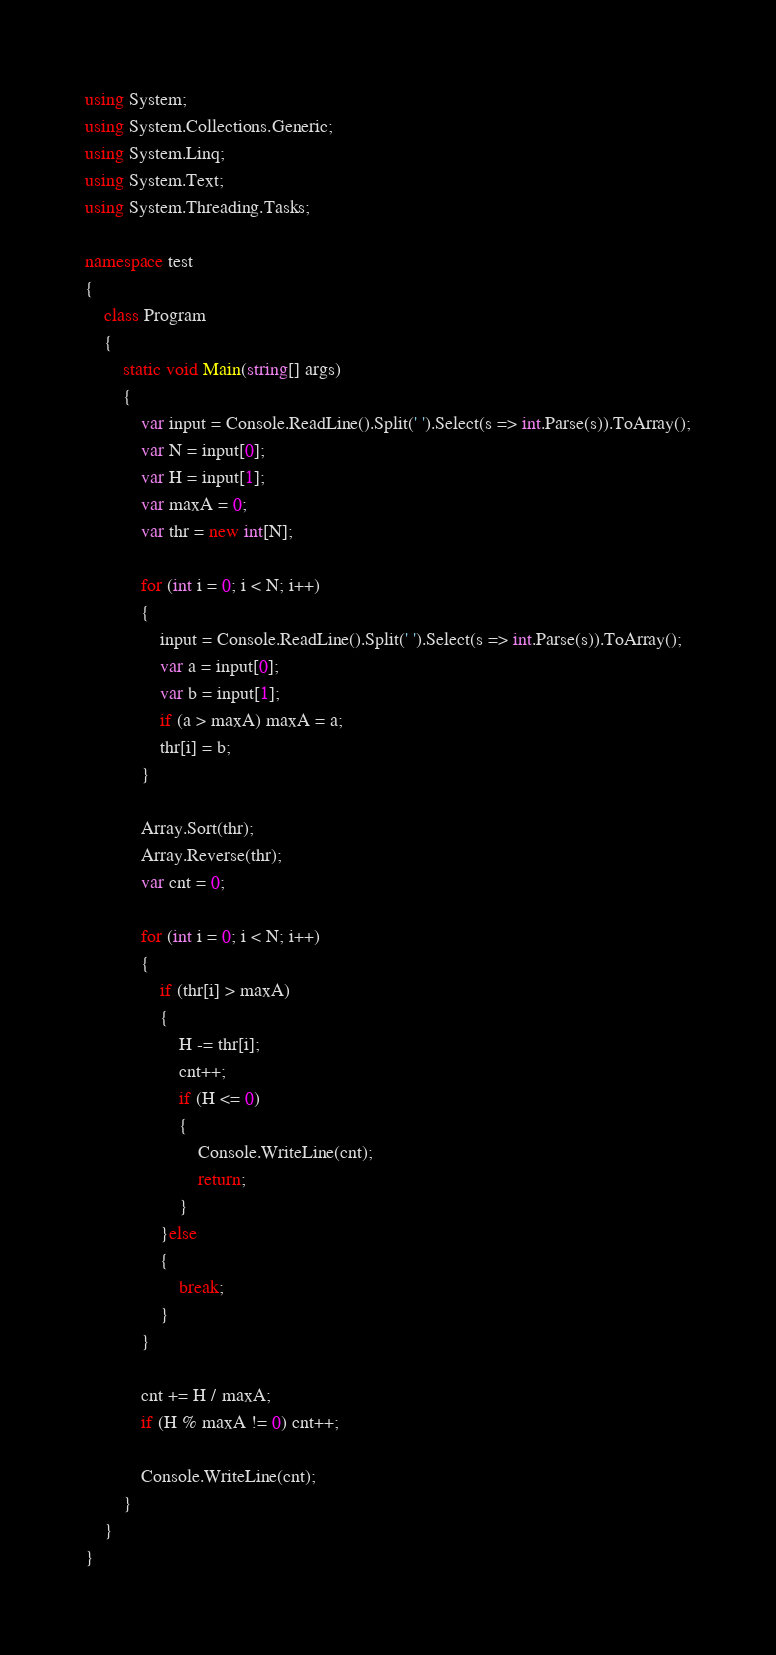Convert code to text. <code><loc_0><loc_0><loc_500><loc_500><_C#_>using System;
using System.Collections.Generic;
using System.Linq;
using System.Text;
using System.Threading.Tasks;

namespace test
{
    class Program
    {
        static void Main(string[] args)
        {
            var input = Console.ReadLine().Split(' ').Select(s => int.Parse(s)).ToArray();
            var N = input[0];
            var H = input[1];
            var maxA = 0;
            var thr = new int[N];

            for (int i = 0; i < N; i++)
            {
                input = Console.ReadLine().Split(' ').Select(s => int.Parse(s)).ToArray();
                var a = input[0];
                var b = input[1];
                if (a > maxA) maxA = a;
                thr[i] = b;
            }

            Array.Sort(thr);
            Array.Reverse(thr);
            var cnt = 0;

            for (int i = 0; i < N; i++)
            {
                if (thr[i] > maxA)
                {
                    H -= thr[i];
                    cnt++;
                    if (H <= 0)
                    {
                        Console.WriteLine(cnt);
                        return;
                    }
                }else
                {
                    break;
                }
            }

            cnt += H / maxA;
            if (H % maxA != 0) cnt++;

            Console.WriteLine(cnt);
        }
    }
}</code> 